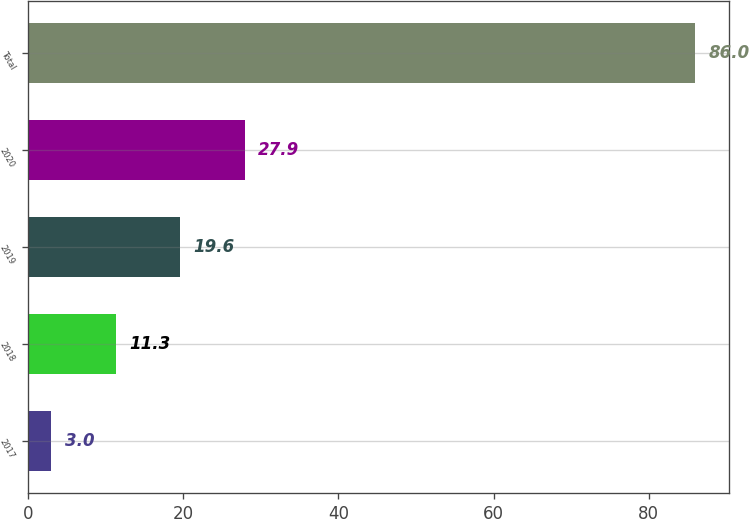Convert chart to OTSL. <chart><loc_0><loc_0><loc_500><loc_500><bar_chart><fcel>2017<fcel>2018<fcel>2019<fcel>2020<fcel>Total<nl><fcel>3<fcel>11.3<fcel>19.6<fcel>27.9<fcel>86<nl></chart> 